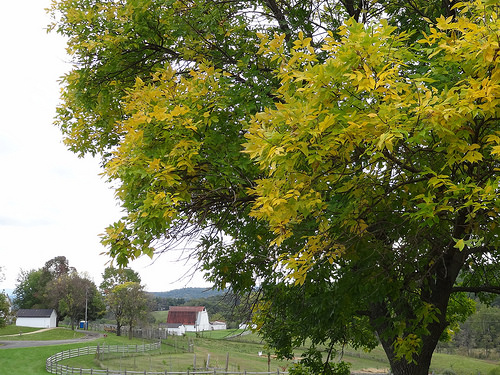<image>
Is there a tree in front of the building? Yes. The tree is positioned in front of the building, appearing closer to the camera viewpoint. 